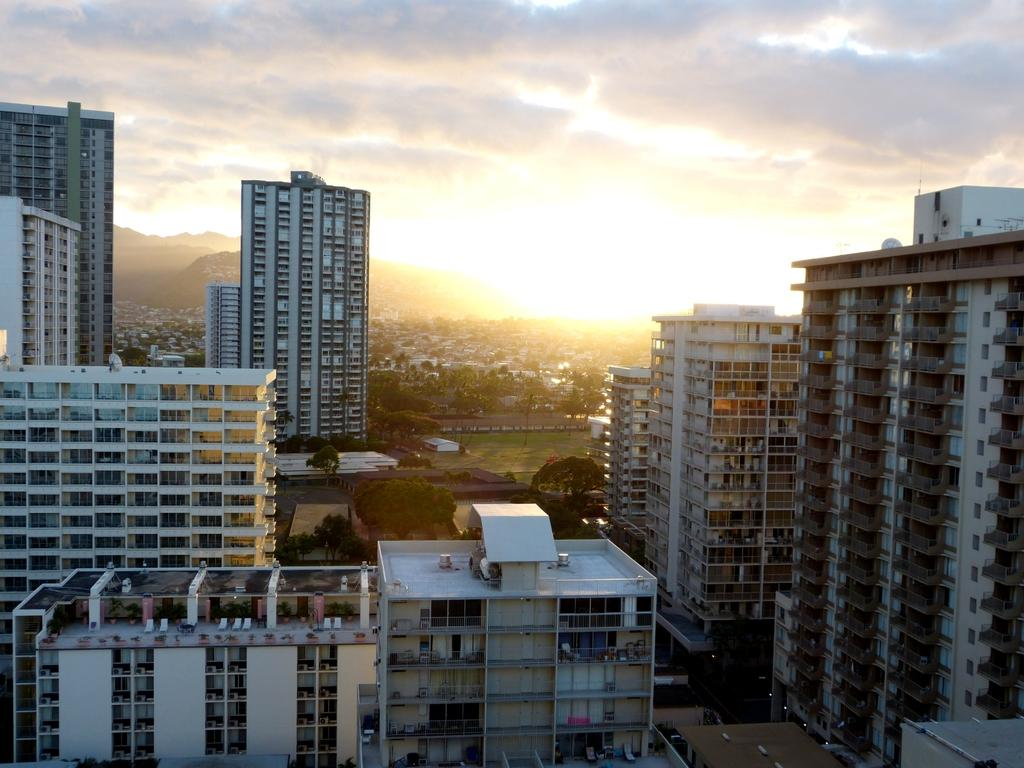What type of view is shown in the image? The image is an aerial view. What type of structures can be seen in the image? There are tower buildings in the image. What natural elements are visible in the image? There is grass and trees visible in the image. What celestial body is visible in the image? The sun is visible in the image. What is the condition of the sky in the background of the image? The sky in the background of the image is cloudy. Can you tell me how many mint leaves are on the trees in the image? There are no mint leaves present on the trees in the image; only grass and trees can be seen. How does the friend in the image react to the kiss? There is no friend or kiss present in the image; it is an aerial view of tower buildings, grass, trees, the sun, and a cloudy sky. 